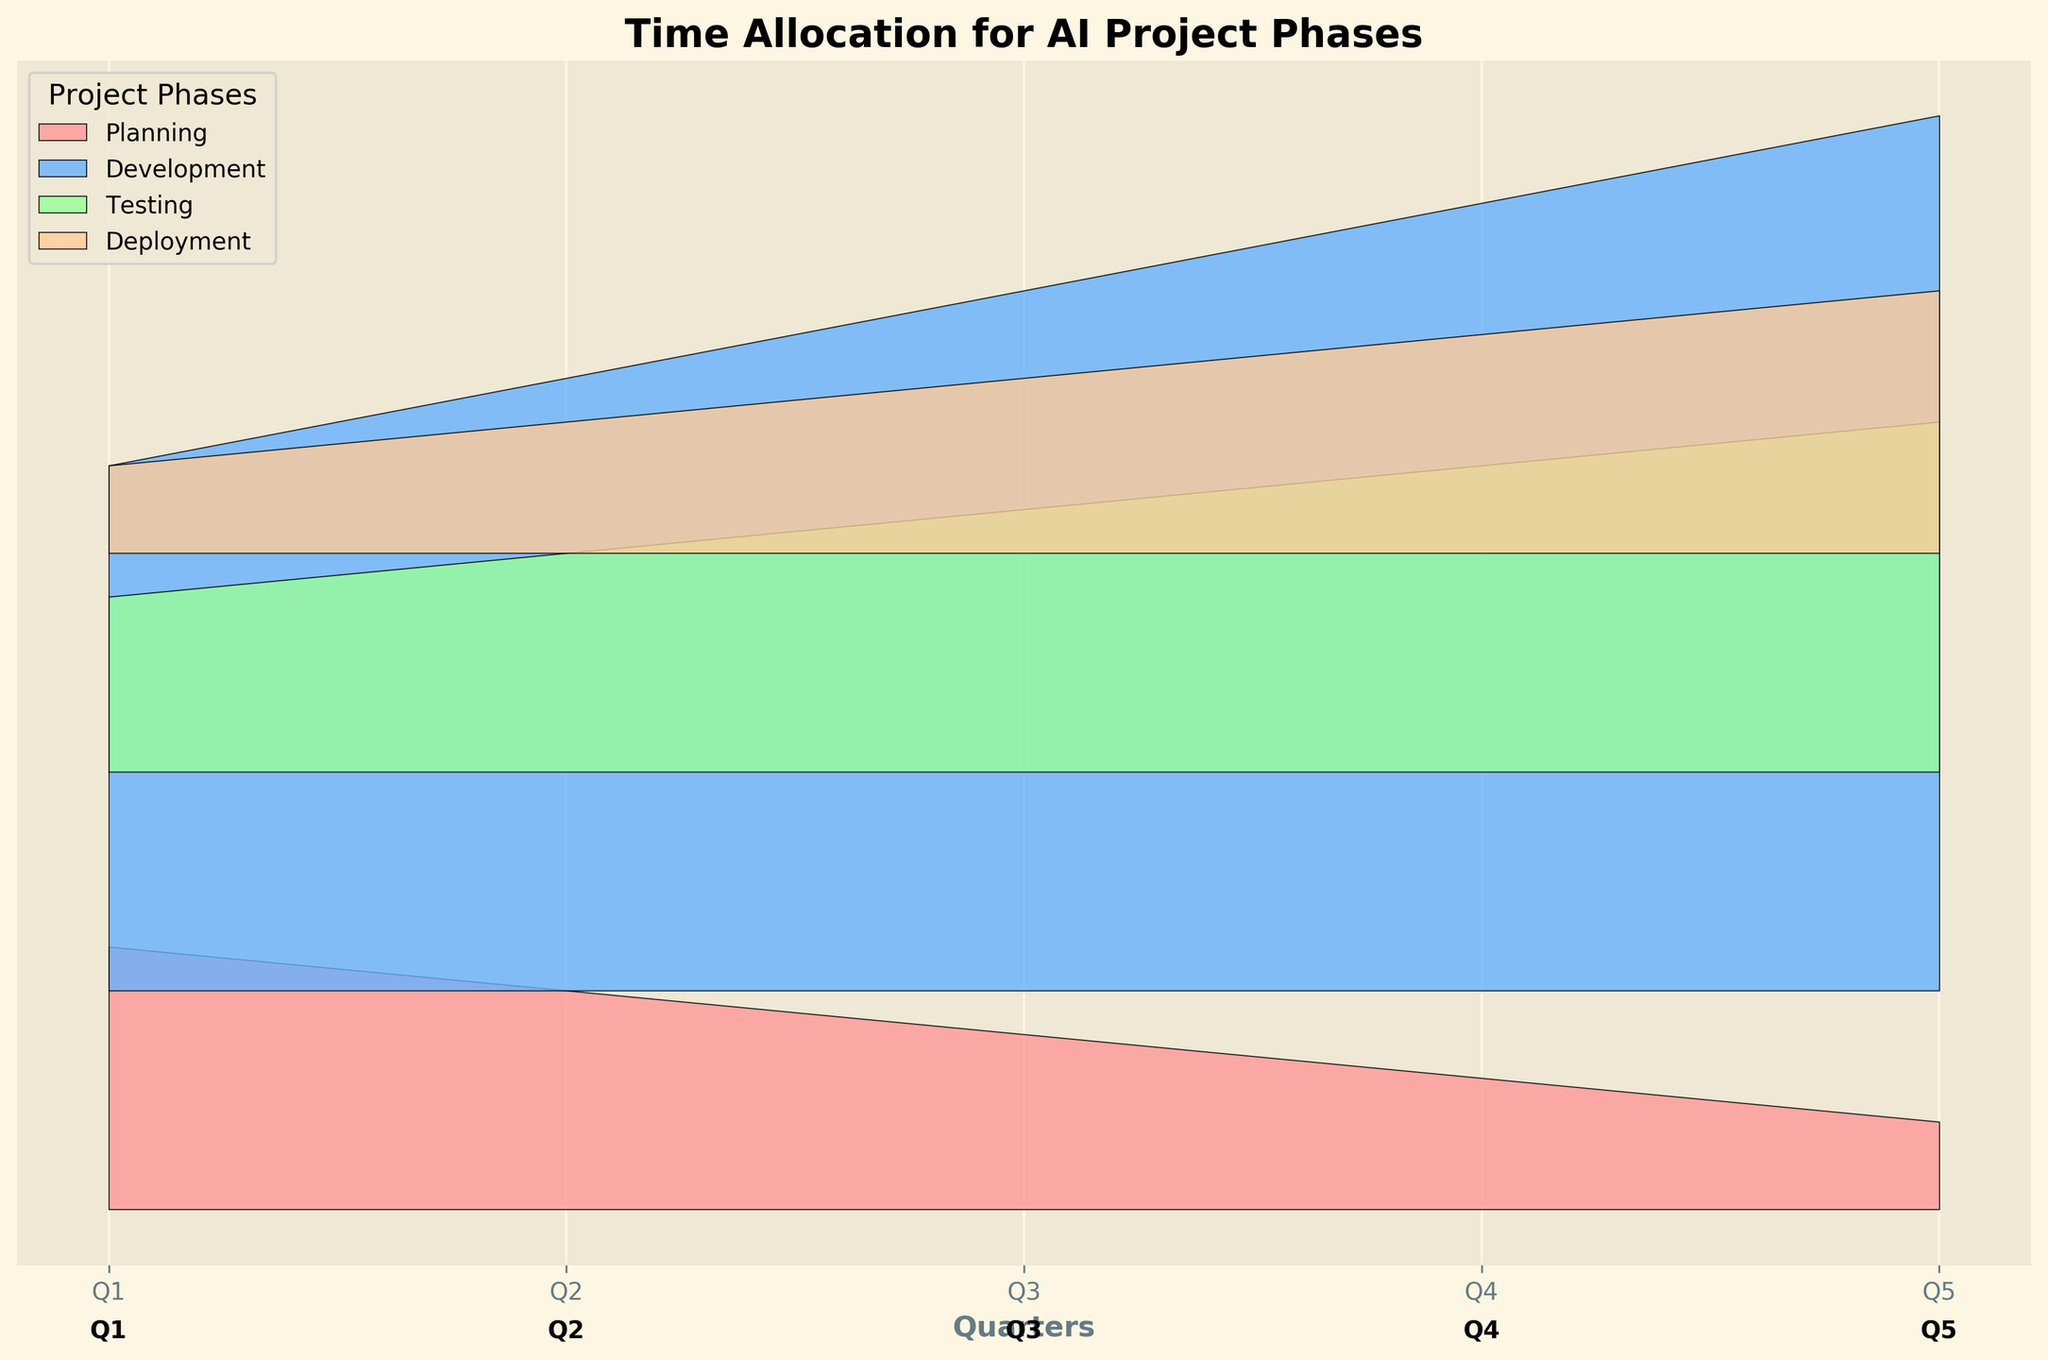What is the title of the Ridgeline plot? The title is positioned at the top of the plot. It provides a summary description of the visualized data’s purpose.
Answer: Time Allocation for AI Project Phases How many quarters are represented in the plot? Count the unique quarter labels along the x-axis to identify the number of quarters.
Answer: 5 Which phase shows a continual increase in hours across all quarters? Inspect each colored layer corresponding to each phase, identifying which one consistently grows higher in its occupied area as you move from left (earlier quarters) to right (later quarters).
Answer: Development How many hours were allocated to Deployment in Q4? Locate the section of the plot where 'Deployment' intersects with 'Q4' on the x-axis and note the height of this segment.
Answer: 100 hours Which phase had the highest increase in hours from Q1 to Q5? Compare the initial and final heights for each phase from Q1 to Q5 and calculate the increase in hours.
Answer: Development Which quarters saw a decrease in Planning hours compared to the previous quarter? Check the 'Planning' layers for each quarter to see where there is a reduction in height compared to the previous quarter.
Answer: Q2, Q3, Q4, Q5 Comparing Q1 and Q2, which phase had the greatest increase in hours? Calculate the difference in height for each phase between Q1 and Q2 and identify the phase with the most significant increase.
Answer: Development What is the total number of hours allocated to Testing over the five quarters? Sum the height segments for 'Testing' across all five quarters.
Answer: 600 hours How did the hours for Planning change from Q1 to Q5? Observe the height of the 'Planning' layers and describe the trend from Q1 to Q5.
Answer: Decreased What is the average number of hours allocated to Deployment over the quarters? Sum the hours for 'Deployment' across all quarters and divide by the number of quarters to obtain the average.
Answer: 80 hours 